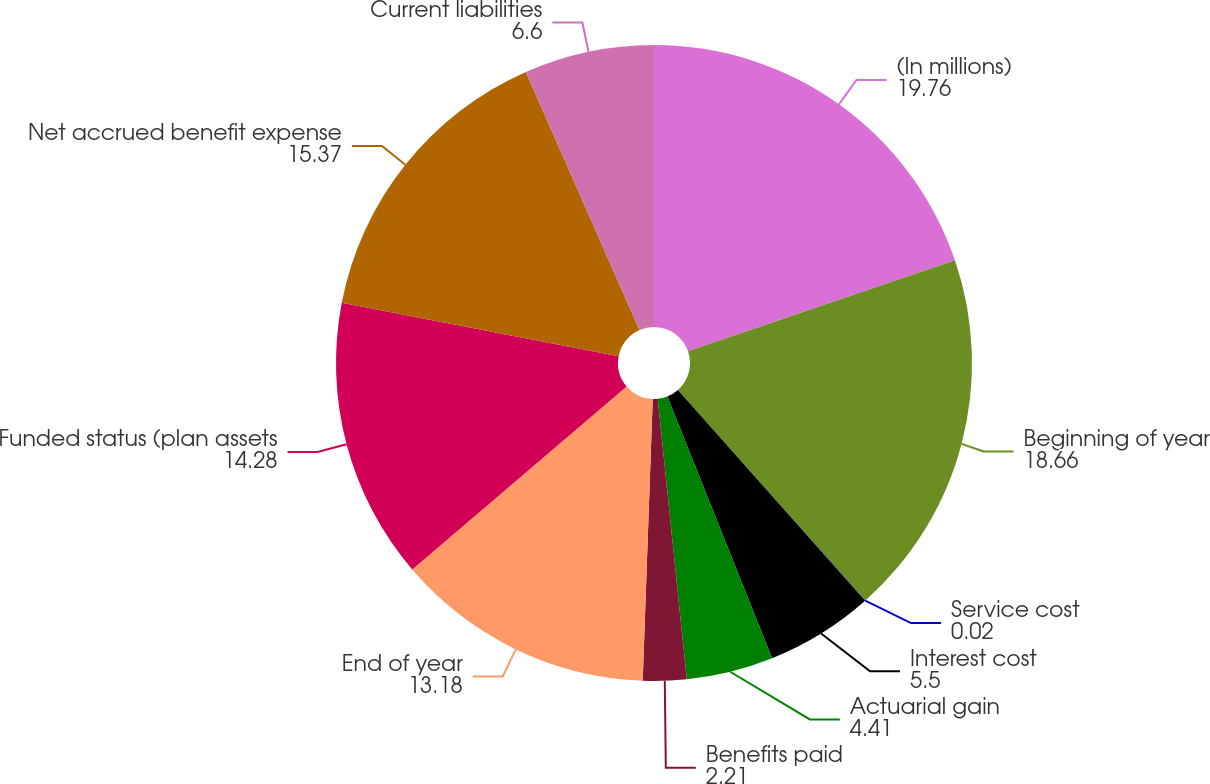<chart> <loc_0><loc_0><loc_500><loc_500><pie_chart><fcel>(In millions)<fcel>Beginning of year<fcel>Service cost<fcel>Interest cost<fcel>Actuarial gain<fcel>Benefits paid<fcel>End of year<fcel>Funded status (plan assets<fcel>Net accrued benefit expense<fcel>Current liabilities<nl><fcel>19.76%<fcel>18.66%<fcel>0.02%<fcel>5.5%<fcel>4.41%<fcel>2.21%<fcel>13.18%<fcel>14.28%<fcel>15.37%<fcel>6.6%<nl></chart> 